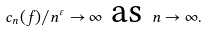Convert formula to latex. <formula><loc_0><loc_0><loc_500><loc_500>c _ { n } ( f ) / n ^ { \varepsilon } \to \infty \text { as } n \to \infty .</formula> 